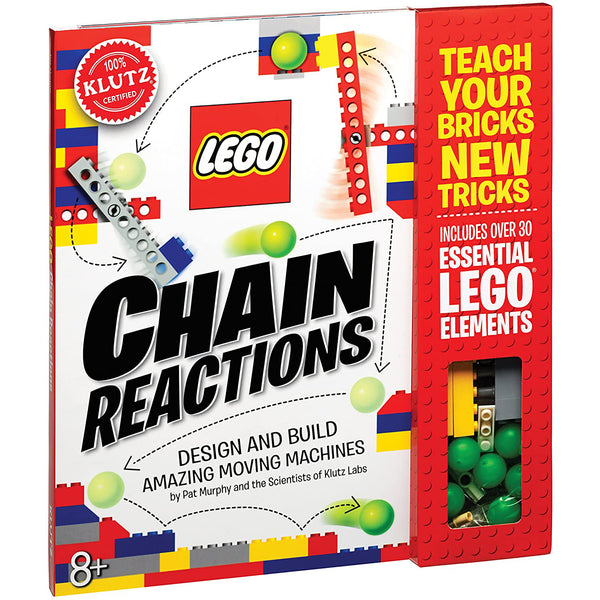Considering the visible LEGO elements through the cut-out window on the cover, what types of simple machines can potentially be built with them, and how might they demonstrate fundamental principles of physics? The visible LEGO elements include gears, balls, and various connecting pieces, which suggests that one could build simple machines like levers, pulleys, or inclined planes. These could demonstrate fundamental physics principles such as leverage, mechanical advantage, and the transfer of energy through a chain reaction. For instance, the gears can be used to create a system that shows how rotational motion can be transferred and how gear ratios affect speed and torque, thereby exploring concepts of energy conservation and force multiplication. 